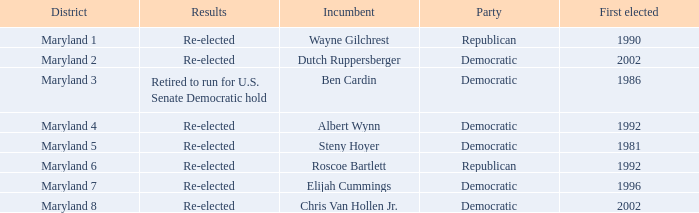What is the party of the maryland 6 district? Republican. 